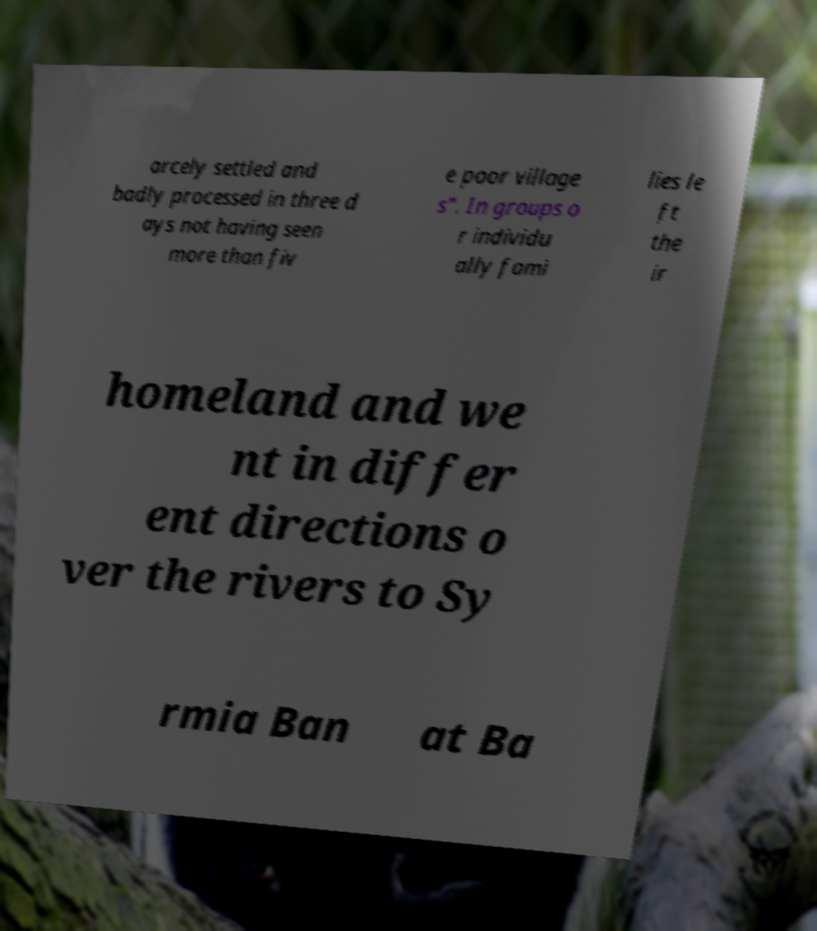I need the written content from this picture converted into text. Can you do that? arcely settled and badly processed in three d ays not having seen more than fiv e poor village s". In groups o r individu ally fami lies le ft the ir homeland and we nt in differ ent directions o ver the rivers to Sy rmia Ban at Ba 